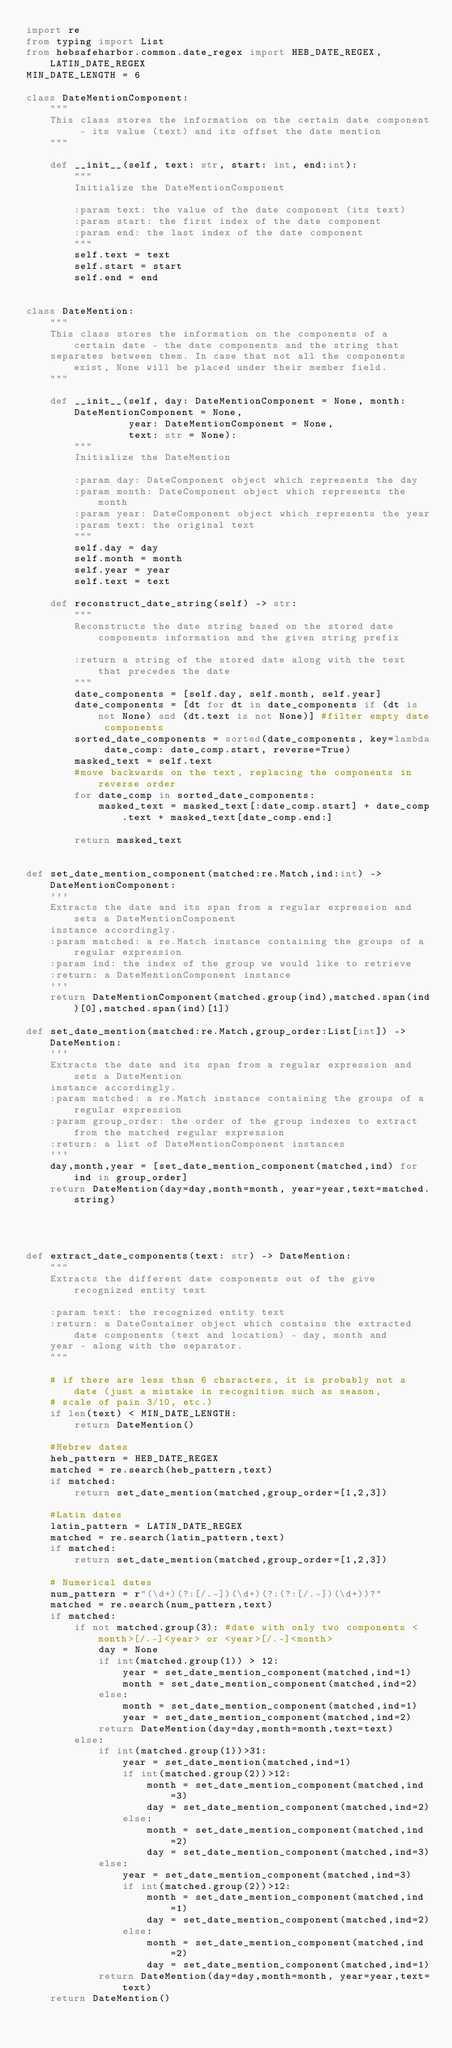Convert code to text. <code><loc_0><loc_0><loc_500><loc_500><_Python_>import re
from typing import List
from hebsafeharbor.common.date_regex import HEB_DATE_REGEX, LATIN_DATE_REGEX
MIN_DATE_LENGTH = 6

class DateMentionComponent:
    """
    This class stores the information on the certain date component - its value (text) and its offset the date mention
    """

    def __init__(self, text: str, start: int, end:int):
        """
        Initialize the DateMentionComponent

        :param text: the value of the date component (its text)
        :param start: the first index of the date component
        :param end: the last index of the date component
        """
        self.text = text
        self.start = start
        self.end = end


class DateMention:
    """
    This class stores the information on the components of a certain date - the date components and the string that
    separates between them. In case that not all the components exist, None will be placed under their member field.
    """

    def __init__(self, day: DateMentionComponent = None, month: DateMentionComponent = None,
                 year: DateMentionComponent = None,
                 text: str = None):
        """
        Initialize the DateMention

        :param day: DateComponent object which represents the day
        :param month: DateComponent object which represents the month
        :param year: DateComponent object which represents the year
        :param text: the original text
        """
        self.day = day
        self.month = month
        self.year = year
        self.text = text

    def reconstruct_date_string(self) -> str:
        """
        Reconstructs the date string based on the stored date components information and the given string prefix

        :return a string of the stored date along with the text that precedes the date
        """
        date_components = [self.day, self.month, self.year]
        date_components = [dt for dt in date_components if (dt is not None) and (dt.text is not None)] #filter empty date components
        sorted_date_components = sorted(date_components, key=lambda date_comp: date_comp.start, reverse=True)
        masked_text = self.text
        #move backwards on the text, replacing the components in reverse order
        for date_comp in sorted_date_components:
            masked_text = masked_text[:date_comp.start] + date_comp.text + masked_text[date_comp.end:]

        return masked_text
 

def set_date_mention_component(matched:re.Match,ind:int) -> DateMentionComponent:
    '''
    Extracts the date and its span from a regular expression and sets a DateMentionComponent 
    instance accordingly.
    :param matched: a re.Match instance containing the groups of a regular expression
    :param ind: the index of the group we would like to retrieve
    :return: a DateMentionComponent instance
    '''
    return DateMentionComponent(matched.group(ind),matched.span(ind)[0],matched.span(ind)[1])

def set_date_mention(matched:re.Match,group_order:List[int]) -> DateMention:
    '''
    Extracts the date and its span from a regular expression and sets a DateMention
    instance accordingly.
    :param matched: a re.Match instance containing the groups of a regular expression
    :param group_order: the order of the group indexes to extract from the matched regular expression
    :return: a list of DateMentionComponent instances
    '''
    day,month,year = [set_date_mention_component(matched,ind) for ind in group_order]
    return DateMention(day=day,month=month, year=year,text=matched.string)




def extract_date_components(text: str) -> DateMention:
    """
    Extracts the different date components out of the give recognized entity text

    :param text: the recognized entity text
    :return: a DateContainer object which contains the extracted date components (text and location) - day, month and
    year - along with the separator.
    """

    # if there are less than 6 characters, it is probably not a date (just a mistake in recognition such as season,
    # scale of pain 3/10, etc.)
    if len(text) < MIN_DATE_LENGTH:
        return DateMention()

    #Hebrew dates
    heb_pattern = HEB_DATE_REGEX
    matched = re.search(heb_pattern,text)
    if matched:
        return set_date_mention(matched,group_order=[1,2,3])
        
    #Latin dates
    latin_pattern = LATIN_DATE_REGEX
    matched = re.search(latin_pattern,text)
    if matched:
        return set_date_mention(matched,group_order=[1,2,3]) 
   
    # Numerical dates
    num_pattern = r"(\d+)(?:[/.-])(\d+)(?:(?:[/.-])(\d+))?"
    matched = re.search(num_pattern,text)
    if matched:
        if not matched.group(3): #date with only two components <month>[/.-]<year> or <year>[/.-]<month>
            day = None
            if int(matched.group(1)) > 12:
                year = set_date_mention_component(matched,ind=1)
                month = set_date_mention_component(matched,ind=2)
            else:
                month = set_date_mention_component(matched,ind=1)
                year = set_date_mention_component(matched,ind=2)
            return DateMention(day=day,month=month,text=text)        
        else:
            if int(matched.group(1))>31:        
                year = set_date_mention(matched,ind=1)
                if int(matched.group(2))>12:
                    month = set_date_mention_component(matched,ind=3)
                    day = set_date_mention_component(matched,ind=2)
                else:
                    month = set_date_mention_component(matched,ind=2)
                    day = set_date_mention_component(matched,ind=3)
            else:
                year = set_date_mention_component(matched,ind=3)
                if int(matched.group(2))>12:
                    month = set_date_mention_component(matched,ind=1)
                    day = set_date_mention_component(matched,ind=2)
                else:
                    month = set_date_mention_component(matched,ind=2)
                    day = set_date_mention_component(matched,ind=1)
            return DateMention(day=day,month=month, year=year,text=text)
    return DateMention()</code> 